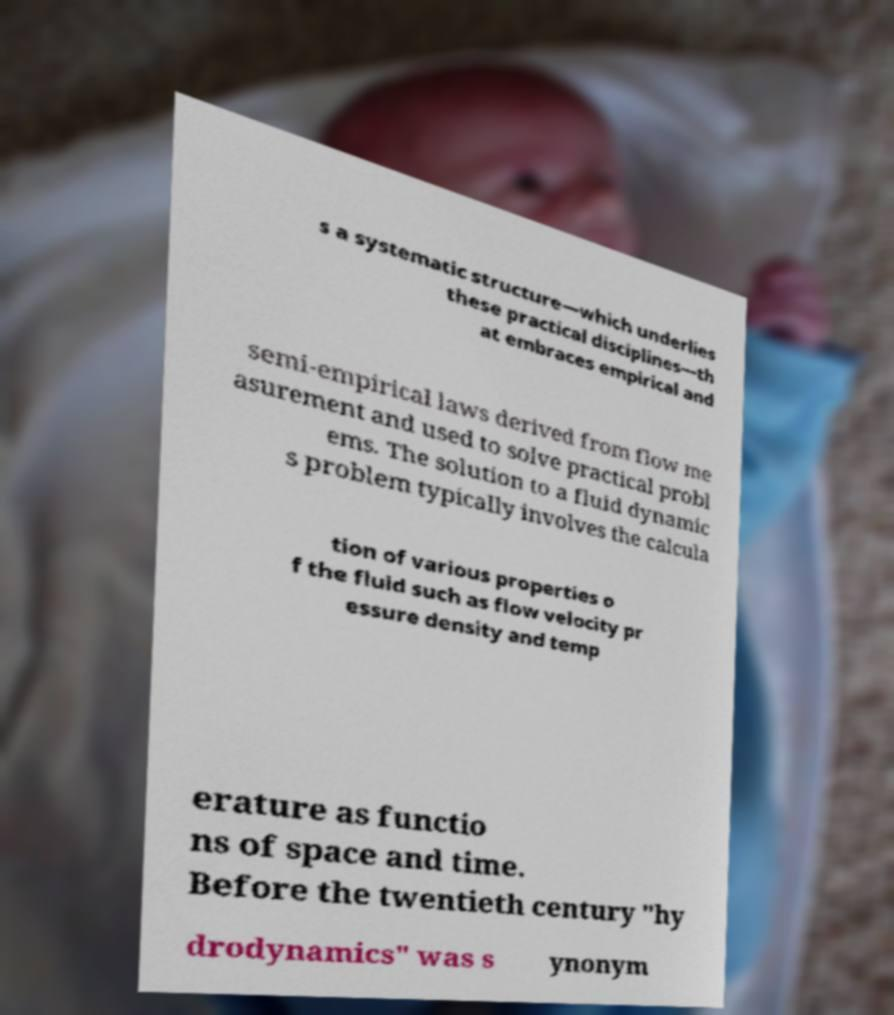There's text embedded in this image that I need extracted. Can you transcribe it verbatim? s a systematic structure—which underlies these practical disciplines—th at embraces empirical and semi-empirical laws derived from flow me asurement and used to solve practical probl ems. The solution to a fluid dynamic s problem typically involves the calcula tion of various properties o f the fluid such as flow velocity pr essure density and temp erature as functio ns of space and time. Before the twentieth century "hy drodynamics" was s ynonym 